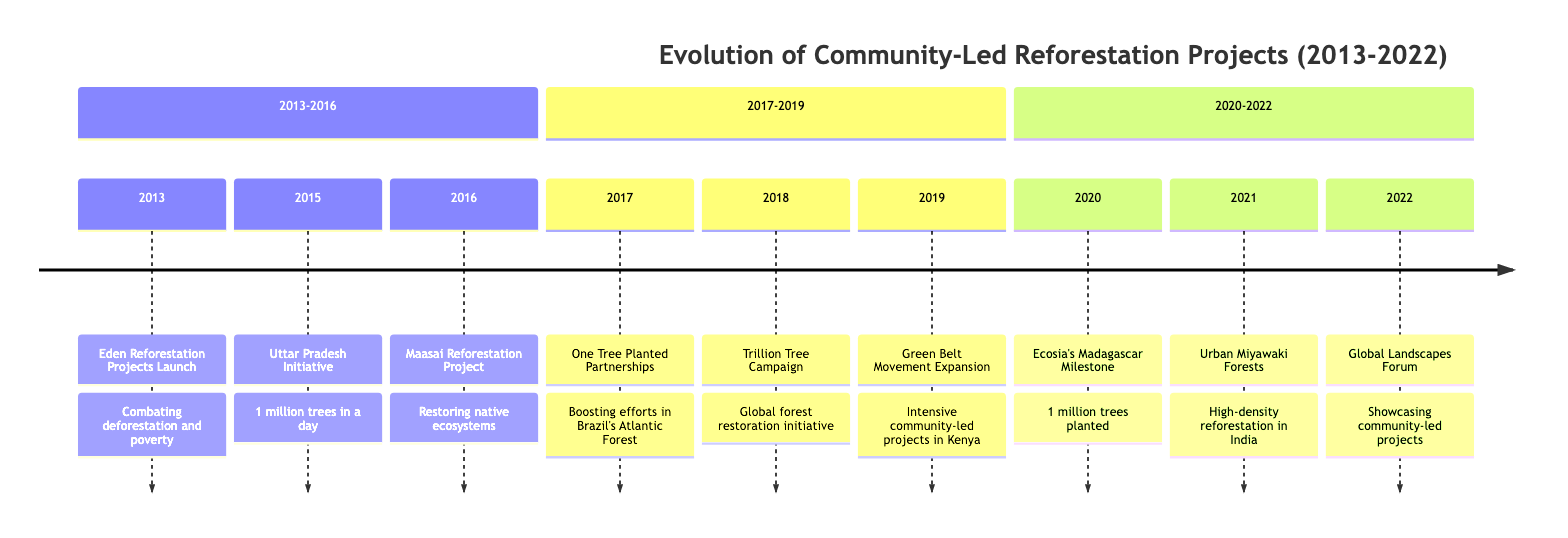What year did Eden Reforestation Projects launch? The event "Launch of Eden Reforestation Projects" is labeled with the year 2013, indicating that this is when the project started.
Answer: 2013 How many trees were grown in Uttar Pradesh in 2015? The event "Community-Led Initiative in Uttar Pradesh" specifies that over 1 million trees were successfully grown in a single day in 2015.
Answer: over 1 million What community started a reforestation project in 2016? The "Maasai Reforestation Project" indicates that it was the Maasai community in Kenya that initiated the project in 2016.
Answer: Maasai community Which campaign was launched in 2018? The timeline in 2018 mentions the "Trillion Tree Campaign," which was inspired by the UN Environment Programme.
Answer: Trillion Tree Campaign What significant milestone did Ecosia achieve in 2020? The entry for the year 2020 states that Ecosia reached the goal of planting over one million trees in Madagascar, marking a significant milestone.
Answer: over one million trees How did community-led projects gain visibility in 2022? The timeline details indicate that community-led reforestation projects were highlighted at the Global Landscapes Forum in 2022.
Answer: Global Landscapes Forum Which year shows the partnership of One Tree Planted with local groups? The event for the year 2017 specifically mentions that One Tree Planted partnered with local communities in Brazil's Atlantic Forest to enhance reforestation efforts.
Answer: 2017 In which year did Indian communities adopt the Miyawaki method? The timeline identifies 2021 as the year when urban communities in India began adopting the Miyawaki method for high-density reforestation.
Answer: 2021 What notable reforestation effort took place in 2019 in Kenya? The entry for 2019 describes the expansion of the Green Belt Movement in Kenya, focusing on more intensive community-led projects.
Answer: Green Belt Movement Expansion 